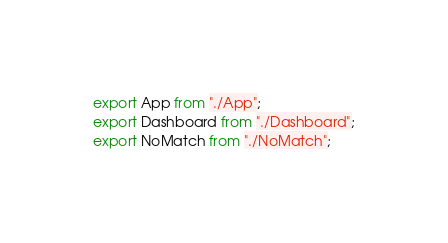<code> <loc_0><loc_0><loc_500><loc_500><_JavaScript_>export App from "./App";
export Dashboard from "./Dashboard";
export NoMatch from "./NoMatch";
</code> 